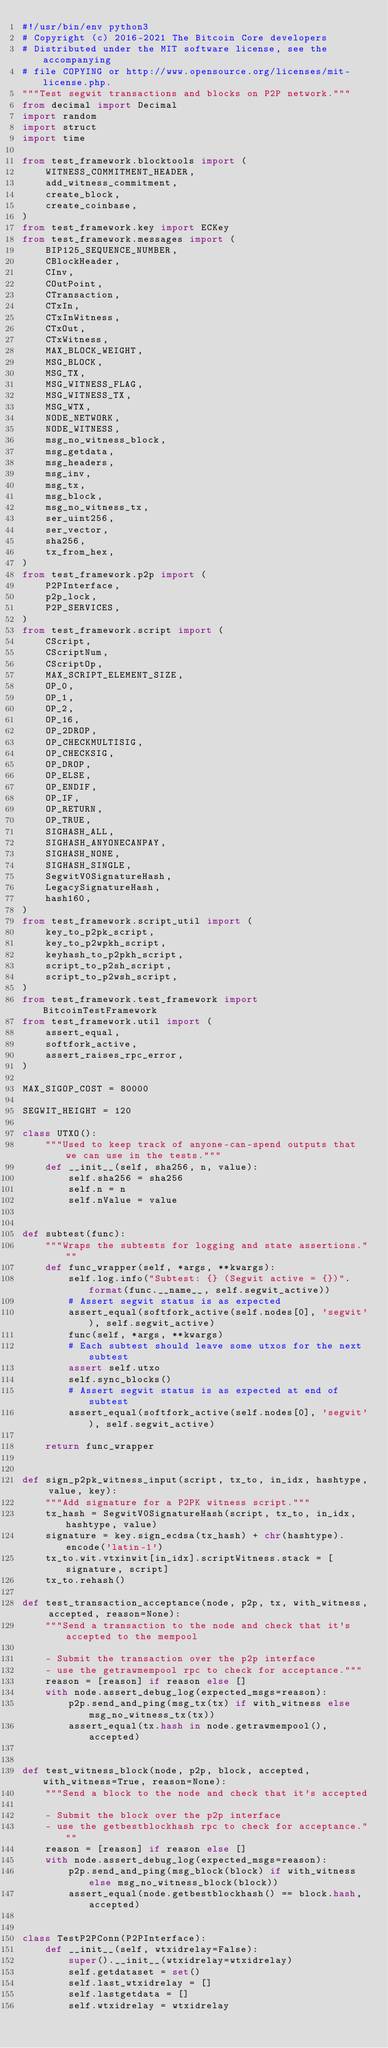Convert code to text. <code><loc_0><loc_0><loc_500><loc_500><_Python_>#!/usr/bin/env python3
# Copyright (c) 2016-2021 The Bitcoin Core developers
# Distributed under the MIT software license, see the accompanying
# file COPYING or http://www.opensource.org/licenses/mit-license.php.
"""Test segwit transactions and blocks on P2P network."""
from decimal import Decimal
import random
import struct
import time

from test_framework.blocktools import (
    WITNESS_COMMITMENT_HEADER,
    add_witness_commitment,
    create_block,
    create_coinbase,
)
from test_framework.key import ECKey
from test_framework.messages import (
    BIP125_SEQUENCE_NUMBER,
    CBlockHeader,
    CInv,
    COutPoint,
    CTransaction,
    CTxIn,
    CTxInWitness,
    CTxOut,
    CTxWitness,
    MAX_BLOCK_WEIGHT,
    MSG_BLOCK,
    MSG_TX,
    MSG_WITNESS_FLAG,
    MSG_WITNESS_TX,
    MSG_WTX,
    NODE_NETWORK,
    NODE_WITNESS,
    msg_no_witness_block,
    msg_getdata,
    msg_headers,
    msg_inv,
    msg_tx,
    msg_block,
    msg_no_witness_tx,
    ser_uint256,
    ser_vector,
    sha256,
    tx_from_hex,
)
from test_framework.p2p import (
    P2PInterface,
    p2p_lock,
    P2P_SERVICES,
)
from test_framework.script import (
    CScript,
    CScriptNum,
    CScriptOp,
    MAX_SCRIPT_ELEMENT_SIZE,
    OP_0,
    OP_1,
    OP_2,
    OP_16,
    OP_2DROP,
    OP_CHECKMULTISIG,
    OP_CHECKSIG,
    OP_DROP,
    OP_ELSE,
    OP_ENDIF,
    OP_IF,
    OP_RETURN,
    OP_TRUE,
    SIGHASH_ALL,
    SIGHASH_ANYONECANPAY,
    SIGHASH_NONE,
    SIGHASH_SINGLE,
    SegwitV0SignatureHash,
    LegacySignatureHash,
    hash160,
)
from test_framework.script_util import (
    key_to_p2pk_script,
    key_to_p2wpkh_script,
    keyhash_to_p2pkh_script,
    script_to_p2sh_script,
    script_to_p2wsh_script,
)
from test_framework.test_framework import BitcoinTestFramework
from test_framework.util import (
    assert_equal,
    softfork_active,
    assert_raises_rpc_error,
)

MAX_SIGOP_COST = 80000

SEGWIT_HEIGHT = 120

class UTXO():
    """Used to keep track of anyone-can-spend outputs that we can use in the tests."""
    def __init__(self, sha256, n, value):
        self.sha256 = sha256
        self.n = n
        self.nValue = value


def subtest(func):
    """Wraps the subtests for logging and state assertions."""
    def func_wrapper(self, *args, **kwargs):
        self.log.info("Subtest: {} (Segwit active = {})".format(func.__name__, self.segwit_active))
        # Assert segwit status is as expected
        assert_equal(softfork_active(self.nodes[0], 'segwit'), self.segwit_active)
        func(self, *args, **kwargs)
        # Each subtest should leave some utxos for the next subtest
        assert self.utxo
        self.sync_blocks()
        # Assert segwit status is as expected at end of subtest
        assert_equal(softfork_active(self.nodes[0], 'segwit'), self.segwit_active)

    return func_wrapper


def sign_p2pk_witness_input(script, tx_to, in_idx, hashtype, value, key):
    """Add signature for a P2PK witness script."""
    tx_hash = SegwitV0SignatureHash(script, tx_to, in_idx, hashtype, value)
    signature = key.sign_ecdsa(tx_hash) + chr(hashtype).encode('latin-1')
    tx_to.wit.vtxinwit[in_idx].scriptWitness.stack = [signature, script]
    tx_to.rehash()

def test_transaction_acceptance(node, p2p, tx, with_witness, accepted, reason=None):
    """Send a transaction to the node and check that it's accepted to the mempool

    - Submit the transaction over the p2p interface
    - use the getrawmempool rpc to check for acceptance."""
    reason = [reason] if reason else []
    with node.assert_debug_log(expected_msgs=reason):
        p2p.send_and_ping(msg_tx(tx) if with_witness else msg_no_witness_tx(tx))
        assert_equal(tx.hash in node.getrawmempool(), accepted)


def test_witness_block(node, p2p, block, accepted, with_witness=True, reason=None):
    """Send a block to the node and check that it's accepted

    - Submit the block over the p2p interface
    - use the getbestblockhash rpc to check for acceptance."""
    reason = [reason] if reason else []
    with node.assert_debug_log(expected_msgs=reason):
        p2p.send_and_ping(msg_block(block) if with_witness else msg_no_witness_block(block))
        assert_equal(node.getbestblockhash() == block.hash, accepted)


class TestP2PConn(P2PInterface):
    def __init__(self, wtxidrelay=False):
        super().__init__(wtxidrelay=wtxidrelay)
        self.getdataset = set()
        self.last_wtxidrelay = []
        self.lastgetdata = []
        self.wtxidrelay = wtxidrelay
</code> 